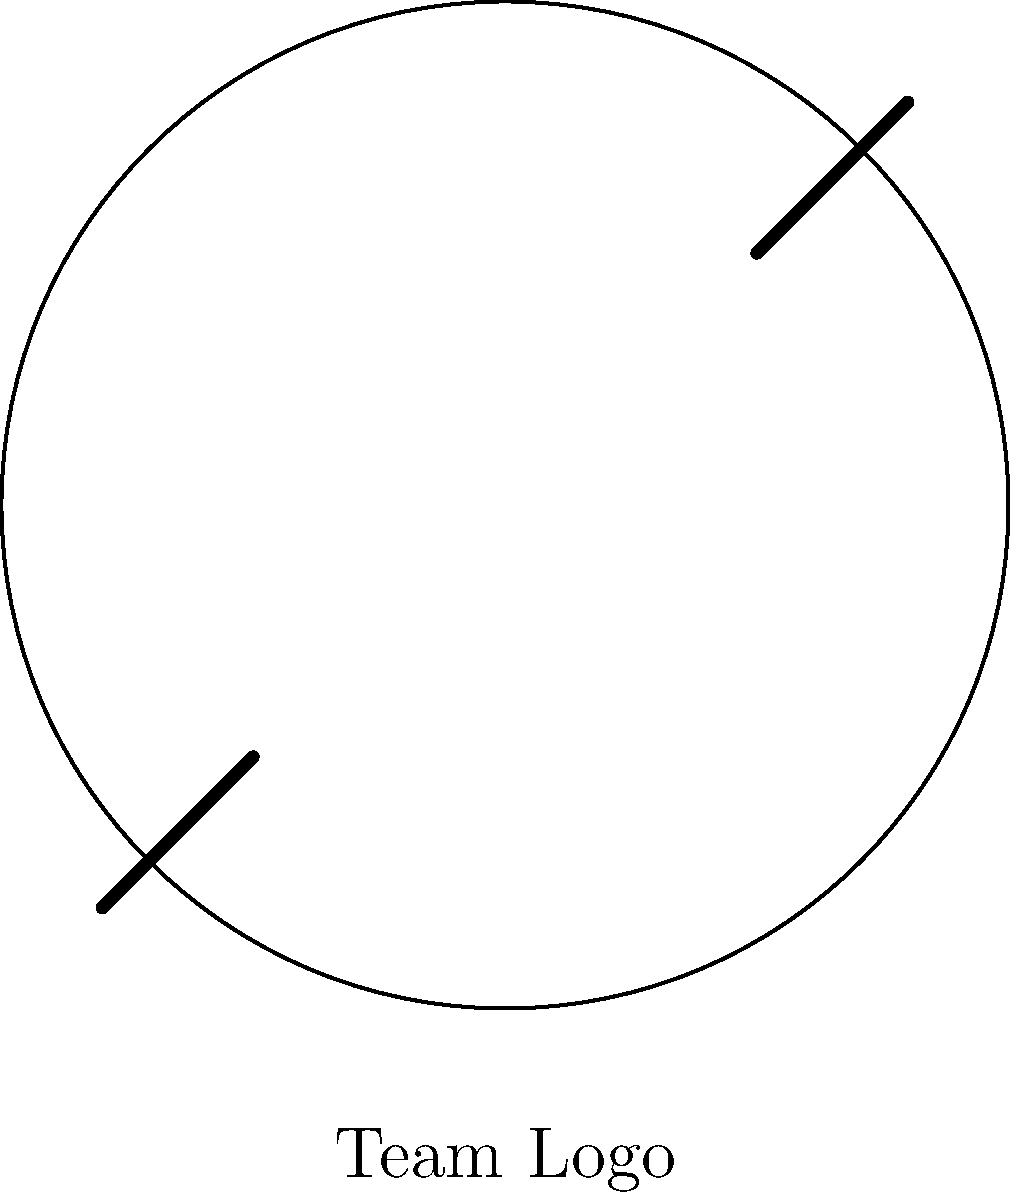Your child's hockey team is designing a new logo. The current design features a circle with two hockey sticks crossing diagonally. How many rotational symmetries does this logo have? To determine the number of rotational symmetries in this logo, we need to follow these steps:

1. Identify the elements of the logo:
   - A circular border
   - Two hockey sticks crossing diagonally

2. Analyze the rotational symmetry:
   - The circle itself has infinite rotational symmetry.
   - However, the hockey sticks limit the rotational symmetry.

3. Find the angles of rotation that bring the logo back to its original position:
   - 0° (original position)
   - 180° (half turn)

4. Count the number of distinct rotations:
   - There are 2 rotations that bring the logo back to its original appearance.

Therefore, the logo has 2 rotational symmetries: the identity rotation (0°) and a 180° rotation.
Answer: 2 